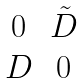Convert formula to latex. <formula><loc_0><loc_0><loc_500><loc_500>\begin{matrix} 0 & \tilde { D } \\ D & 0 \end{matrix}</formula> 